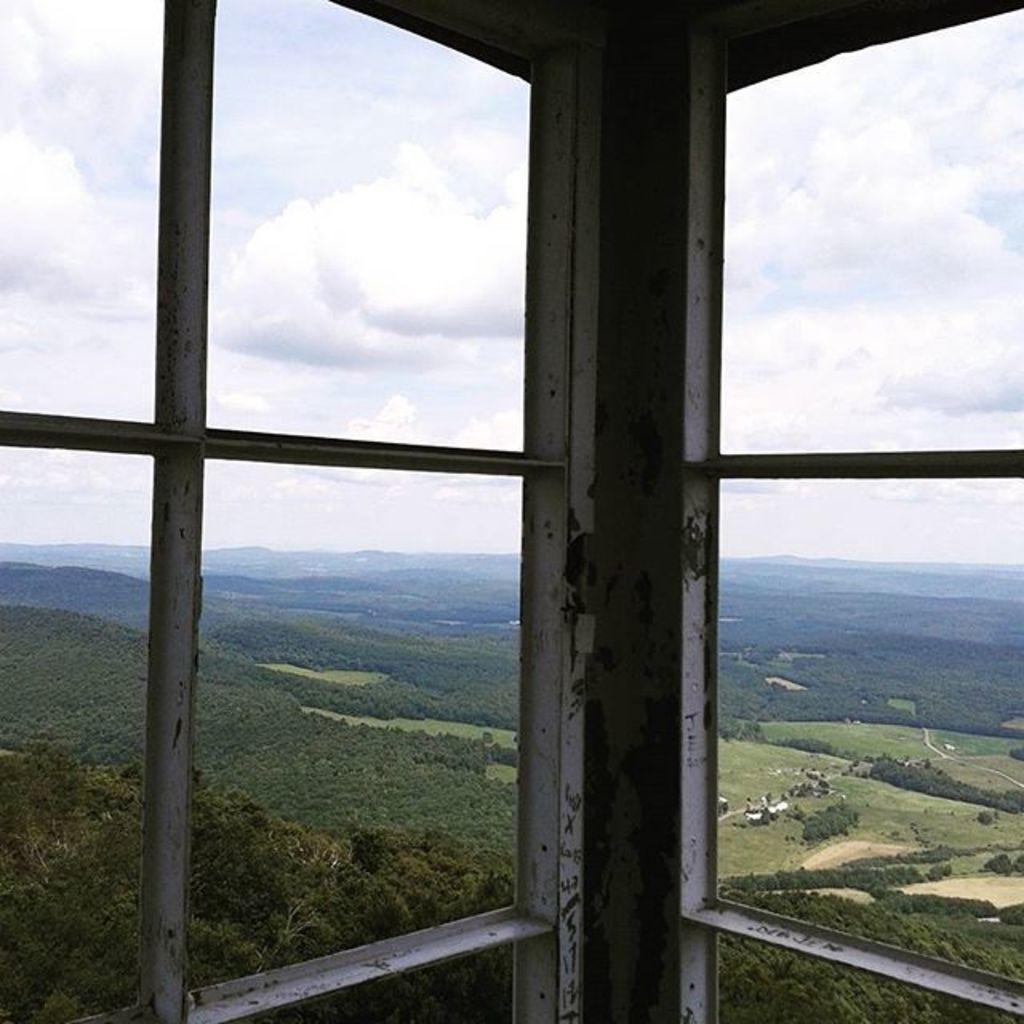Please provide a concise description of this image. In this image we can see windows with iron rods. Through that we can see trees and hills. Also there is sky with clouds. 